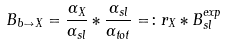<formula> <loc_0><loc_0><loc_500><loc_500>B _ { b \to X } = \frac { \Gamma _ { X } } { \Gamma _ { s l } } * \frac { \Gamma _ { s l } } { \Gamma _ { t o t } } = \colon r _ { X } * B _ { s l } ^ { e x p }</formula> 